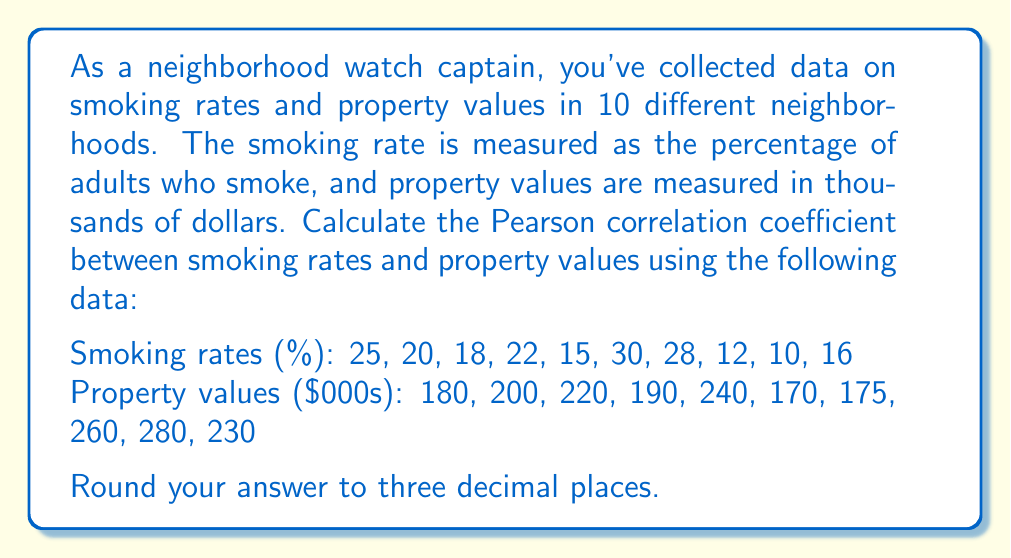Teach me how to tackle this problem. To calculate the Pearson correlation coefficient between smoking rates and property values, we'll follow these steps:

1. Calculate the means of both variables:
   $\bar{x} = \frac{\sum x_i}{n}$ (smoking rates)
   $\bar{y} = \frac{\sum y_i}{n}$ (property values)

2. Calculate the deviations from the means:
   $x_i - \bar{x}$ and $y_i - \bar{y}$

3. Calculate the products of the deviations:
   $(x_i - \bar{x})(y_i - \bar{y})$

4. Sum the products of deviations:
   $\sum (x_i - \bar{x})(y_i - \bar{y})$

5. Calculate the sum of squared deviations for each variable:
   $\sum (x_i - \bar{x})^2$ and $\sum (y_i - \bar{y})^2$

6. Apply the Pearson correlation coefficient formula:
   $$r = \frac{\sum (x_i - \bar{x})(y_i - \bar{y})}{\sqrt{\sum (x_i - \bar{x})^2 \sum (y_i - \bar{y})^2}}$$

Step 1:
$\bar{x} = \frac{25 + 20 + 18 + 22 + 15 + 30 + 28 + 12 + 10 + 16}{10} = 19.6$
$\bar{y} = \frac{180 + 200 + 220 + 190 + 240 + 170 + 175 + 260 + 280 + 230}{10} = 214.5$

Steps 2-5:
| $x_i$ | $y_i$ | $x_i - \bar{x}$ | $y_i - \bar{y}$ | $(x_i - \bar{x})(y_i - \bar{y})$ | $(x_i - \bar{x})^2$ | $(y_i - \bar{y})^2$ |
|-------|-------|-----------------|-----------------|----------------------------------|---------------------|---------------------|
| 25    | 180   | 5.4             | -34.5           | -186.3                           | 29.16               | 1190.25             |
| 20    | 200   | 0.4             | -14.5           | -5.8                             | 0.16                | 210.25              |
| 18    | 220   | -1.6            | 5.5             | -8.8                             | 2.56                | 30.25               |
| 22    | 190   | 2.4             | -24.5           | -58.8                            | 5.76                | 600.25              |
| 15    | 240   | -4.6            | 25.5            | -117.3                           | 21.16               | 650.25              |
| 30    | 170   | 10.4            | -44.5           | -462.8                           | 108.16              | 1980.25             |
| 28    | 175   | 8.4             | -39.5           | -331.8                           | 70.56               | 1560.25             |
| 12    | 260   | -7.6            | 45.5            | -345.8                           | 57.76               | 2070.25             |
| 10    | 280   | -9.6            | 65.5            | -628.8                           | 92.16               | 4290.25             |
| 16    | 230   | -3.6            | 15.5            | -55.8                            | 12.96               | 240.25              |

Sum of $(x_i - \bar{x})(y_i - \bar{y}) = -2202$
Sum of $(x_i - \bar{x})^2 = 400.4$
Sum of $(y_i - \bar{y})^2 = 12822.5$

Step 6:
$$r = \frac{-2202}{\sqrt{400.4 \times 12822.5}} = -0.9731$$

Rounding to three decimal places: -0.973
Answer: -0.973 